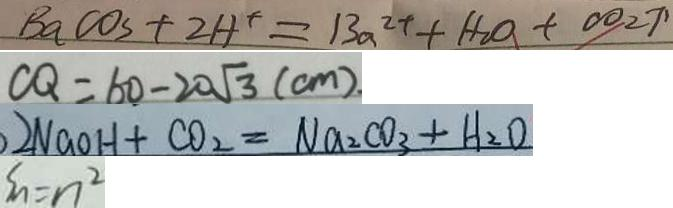<formula> <loc_0><loc_0><loc_500><loc_500>B a C O _ { 3 } + 2 H ^ { + } = 1 3 a ^ { 2 + } + H _ { 2 } O + \infty _ { 2 } \uparrow 
 C Q = 6 0 - 2 0 \sqrt { 3 } ( c m ) . 
 2 N a O H + C O _ { 2 } = N a _ { 2 } C O _ { 3 } + H _ { 2 } O 
 S _ { n } = n ^ { 2 }</formula> 